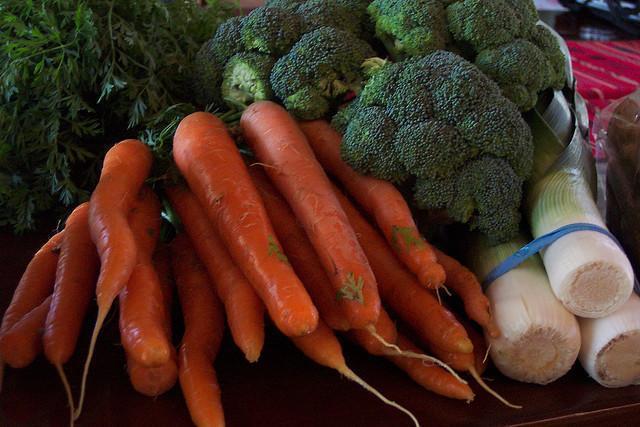What is a collective name given to the food options above?
Choose the correct response, then elucidate: 'Answer: answer
Rationale: rationale.'
Options: Fruits, meat, nuts, veggies. Answer: veggies.
Rationale: All of these produce options are called vegetables. 